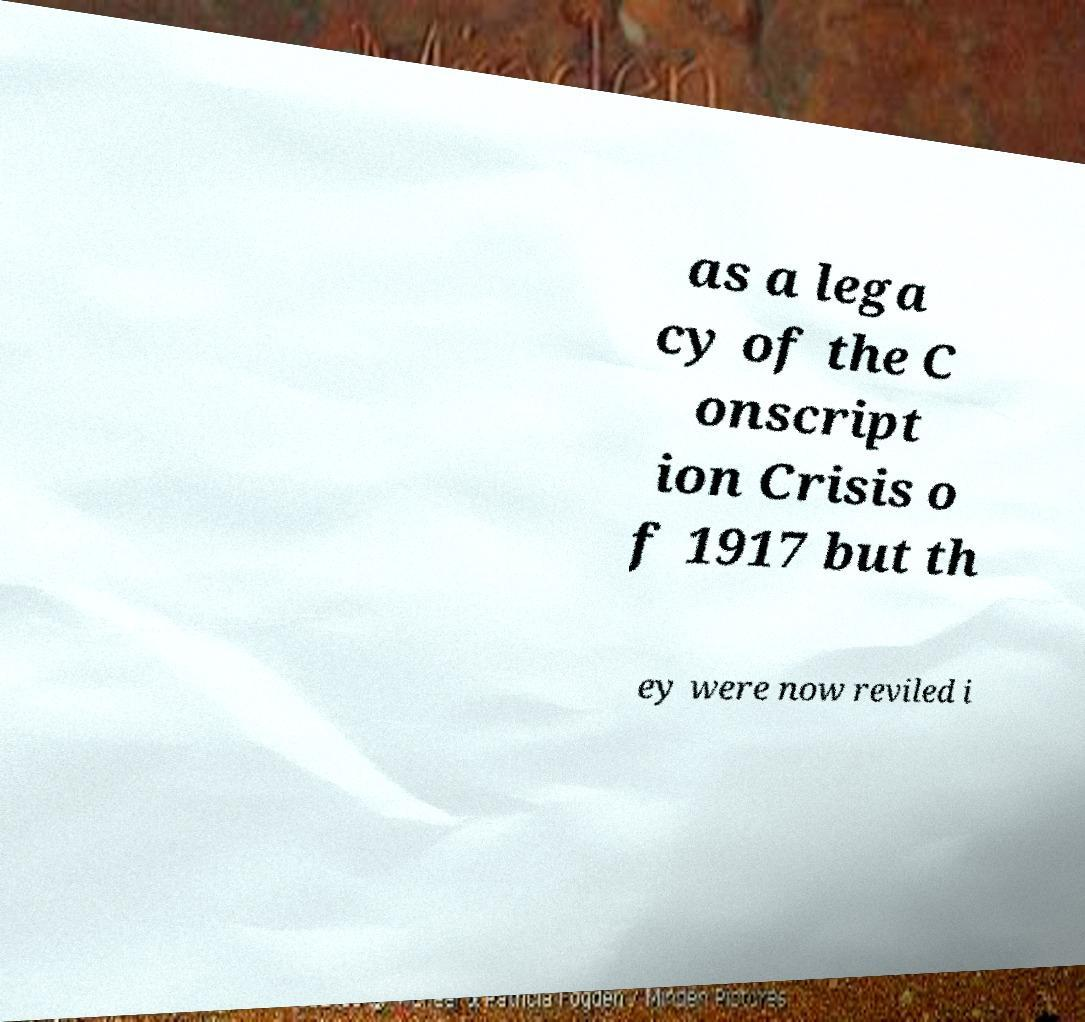For documentation purposes, I need the text within this image transcribed. Could you provide that? as a lega cy of the C onscript ion Crisis o f 1917 but th ey were now reviled i 